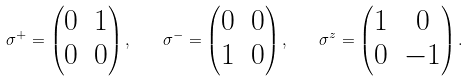Convert formula to latex. <formula><loc_0><loc_0><loc_500><loc_500>\sigma ^ { + } = \begin{pmatrix} 0 & 1 \\ 0 & 0 \end{pmatrix} , \quad \sigma ^ { - } = \begin{pmatrix} 0 & 0 \\ 1 & 0 \end{pmatrix} , \quad \sigma ^ { z } = \begin{pmatrix} 1 & 0 \\ 0 & - 1 \end{pmatrix} .</formula> 